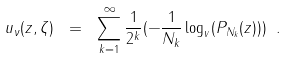<formula> <loc_0><loc_0><loc_500><loc_500>u _ { \nu } ( z , \zeta ) \ = \ \sum _ { k = 1 } ^ { \infty } \frac { 1 } { 2 ^ { k } } ( - \frac { 1 } { N _ { k } } \log _ { v } ( P _ { N _ { k } } ( z ) ) ) \ .</formula> 